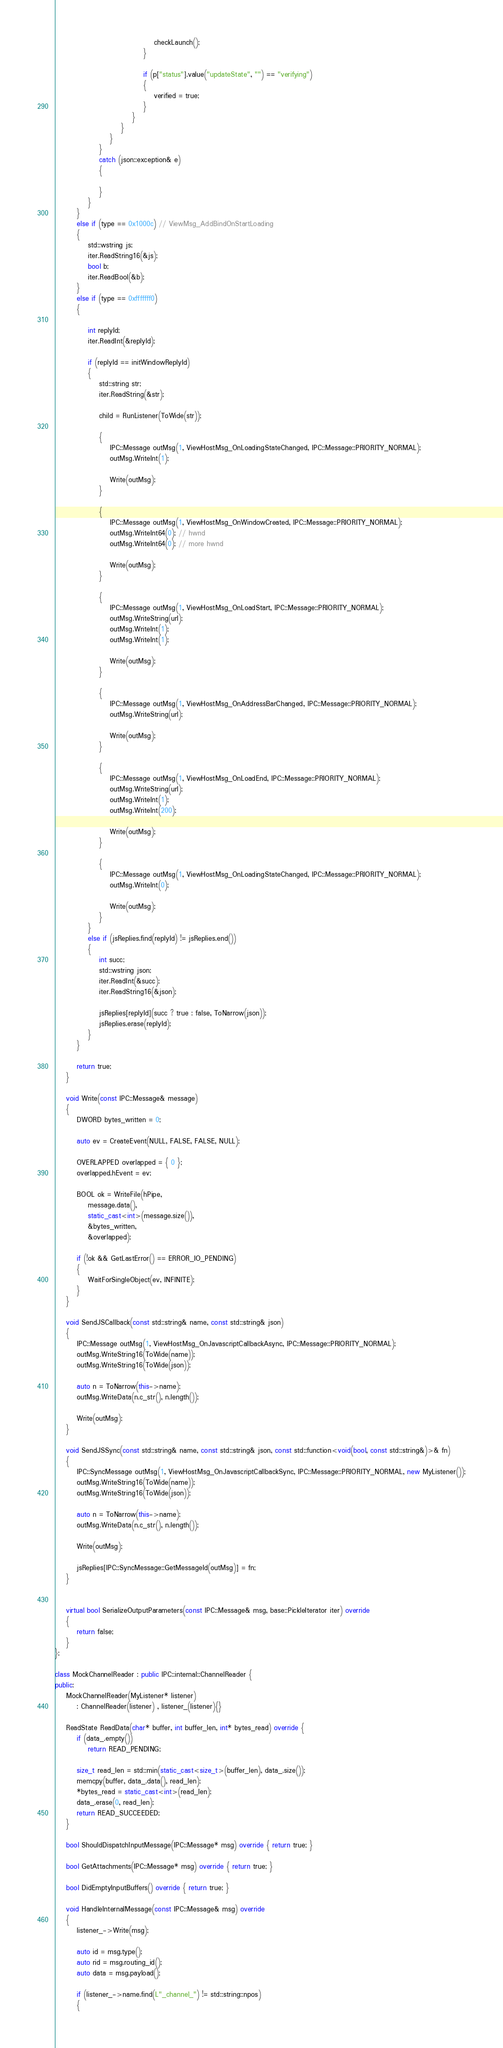<code> <loc_0><loc_0><loc_500><loc_500><_C++_>									checkLaunch();
								}

								if (p["status"].value("updateState", "") == "verifying")
								{
									verified = true;
								}
							}
						}
					}
				}
				catch (json::exception& e)
				{

				}
			}
		}
		else if (type == 0x1000c) // ViewMsg_AddBindOnStartLoading
		{
			std::wstring js;
			iter.ReadString16(&js);
			bool b;
			iter.ReadBool(&b);
		}
		else if (type == 0xfffffff0)
		{

			int replyId;
			iter.ReadInt(&replyId);

			if (replyId == initWindowReplyId)
			{
				std::string str;
				iter.ReadString(&str);

				child = RunListener(ToWide(str));

				{
					IPC::Message outMsg(1, ViewHostMsg_OnLoadingStateChanged, IPC::Message::PRIORITY_NORMAL);
					outMsg.WriteInt(1);

					Write(outMsg);
				}

				{
					IPC::Message outMsg(1, ViewHostMsg_OnWindowCreated, IPC::Message::PRIORITY_NORMAL);
					outMsg.WriteInt64(0); // hwnd
					outMsg.WriteInt64(0); // more hwnd

					Write(outMsg);
				}

				{
					IPC::Message outMsg(1, ViewHostMsg_OnLoadStart, IPC::Message::PRIORITY_NORMAL);
					outMsg.WriteString(url);
					outMsg.WriteInt(1);
					outMsg.WriteInt(1);

					Write(outMsg);
				}

				{
					IPC::Message outMsg(1, ViewHostMsg_OnAddressBarChanged, IPC::Message::PRIORITY_NORMAL);
					outMsg.WriteString(url);

					Write(outMsg);
				}

				{
					IPC::Message outMsg(1, ViewHostMsg_OnLoadEnd, IPC::Message::PRIORITY_NORMAL);
					outMsg.WriteString(url);
					outMsg.WriteInt(1);
					outMsg.WriteInt(200);

					Write(outMsg);
				}

				{
					IPC::Message outMsg(1, ViewHostMsg_OnLoadingStateChanged, IPC::Message::PRIORITY_NORMAL);
					outMsg.WriteInt(0);

					Write(outMsg);
				}
			}
			else if (jsReplies.find(replyId) != jsReplies.end())
			{
				int succ;
				std::wstring json;
				iter.ReadInt(&succ);
				iter.ReadString16(&json);

				jsReplies[replyId](succ ? true : false, ToNarrow(json));
				jsReplies.erase(replyId);
			}
		}

		return true;
	}

	void Write(const IPC::Message& message)
	{
		DWORD bytes_written = 0;

		auto ev = CreateEvent(NULL, FALSE, FALSE, NULL);

		OVERLAPPED overlapped = { 0 };
		overlapped.hEvent = ev;

		BOOL ok = WriteFile(hPipe,
			message.data(),
			static_cast<int>(message.size()),
			&bytes_written,
			&overlapped);

		if (!ok && GetLastError() == ERROR_IO_PENDING)
		{
			WaitForSingleObject(ev, INFINITE);
		}
	}

	void SendJSCallback(const std::string& name, const std::string& json)
	{
		IPC::Message outMsg(1, ViewHostMsg_OnJavascriptCallbackAsync, IPC::Message::PRIORITY_NORMAL);
		outMsg.WriteString16(ToWide(name));
		outMsg.WriteString16(ToWide(json));

		auto n = ToNarrow(this->name);
		outMsg.WriteData(n.c_str(), n.length());

		Write(outMsg);
	}

	void SendJSSync(const std::string& name, const std::string& json, const std::function<void(bool, const std::string&)>& fn)
	{
		IPC::SyncMessage outMsg(1, ViewHostMsg_OnJavascriptCallbackSync, IPC::Message::PRIORITY_NORMAL, new MyListener());
		outMsg.WriteString16(ToWide(name));
		outMsg.WriteString16(ToWide(json));

		auto n = ToNarrow(this->name);
		outMsg.WriteData(n.c_str(), n.length());

		Write(outMsg);

		jsReplies[IPC::SyncMessage::GetMessageId(outMsg)] = fn;
	}


	virtual bool SerializeOutputParameters(const IPC::Message& msg, base::PickleIterator iter) override
	{
		return false;
	}
};

class MockChannelReader : public IPC::internal::ChannelReader {
public:
	MockChannelReader(MyListener* listener)
		: ChannelReader(listener) , listener_(listener){}

	ReadState ReadData(char* buffer, int buffer_len, int* bytes_read) override {
		if (data_.empty())
			return READ_PENDING;

		size_t read_len = std::min(static_cast<size_t>(buffer_len), data_.size());
		memcpy(buffer, data_.data(), read_len);
		*bytes_read = static_cast<int>(read_len);
		data_.erase(0, read_len);
		return READ_SUCCEEDED;
	}

	bool ShouldDispatchInputMessage(IPC::Message* msg) override { return true; }

	bool GetAttachments(IPC::Message* msg) override { return true; }

	bool DidEmptyInputBuffers() override { return true; }

	void HandleInternalMessage(const IPC::Message& msg) override
	{
		listener_->Write(msg);

		auto id = msg.type();
		auto rid = msg.routing_id();
		auto data = msg.payload();

		if (listener_->name.find(L"_channel_") != std::string::npos)
		{</code> 